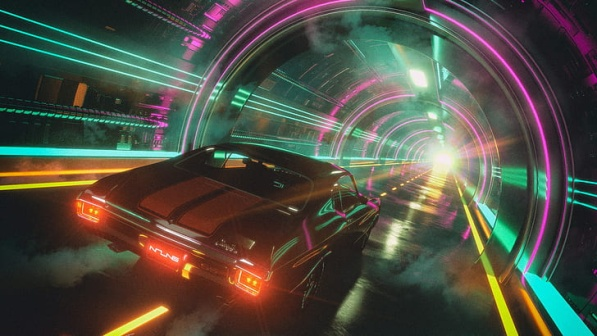Can you describe the main features of this image for me? The image presents a dynamic and vibrant scene set in a futuristic city. At the center, a sleek black sports car with glowing red taillights and a visible license plate is in motion, exuding a sense of speed and energy. It is driving on a smoothly paved road marked with yellow lines, clearly indicating direction and movement.

The car is within a tunnel that features a series of artistically designed arches, bathed in a stunning array of neon lights in vibrant blue, pink, and purple hues. These neon lights create a radiant glow and reflections on the car and the tunnel walls, intensifying the futuristic ambiance of the scene.

In the background, the cityscape emerges with towering buildings that stretch into the horizon. The buildings are somewhat blurred, adding depth and emphasizing the focus on the car and the tunnel. A brilliant white light at the end of the tunnel signifies its exit or could be an intense point of illumination within the city.

Overall, the image stunningly captures the essence of a high-speed journey through a neon-lit tunnel, showcasing the interplay of colors, light, and architectural elements that combine to form a captivating futuristic vista. 